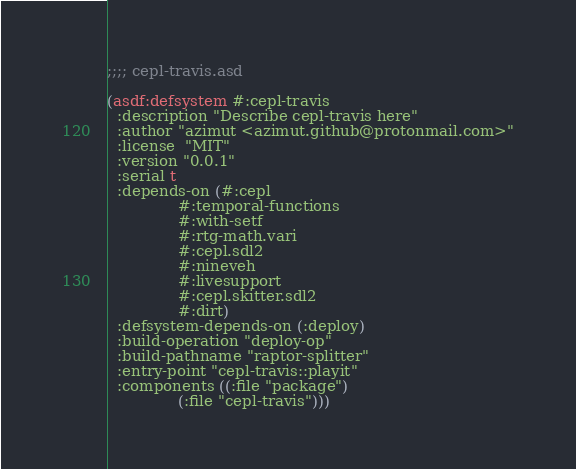Convert code to text. <code><loc_0><loc_0><loc_500><loc_500><_Lisp_>;;;; cepl-travis.asd

(asdf:defsystem #:cepl-travis
  :description "Describe cepl-travis here"
  :author "azimut <azimut.github@protonmail.com>"
  :license  "MIT"
  :version "0.0.1"
  :serial t
  :depends-on (#:cepl
               #:temporal-functions
               #:with-setf
               #:rtg-math.vari
               #:cepl.sdl2
               #:nineveh
               #:livesupport
               #:cepl.skitter.sdl2
               #:dirt)
  :defsystem-depends-on (:deploy)
  :build-operation "deploy-op"
  :build-pathname "raptor-splitter"
  :entry-point "cepl-travis::playit"
  :components ((:file "package")
               (:file "cepl-travis")))
</code> 